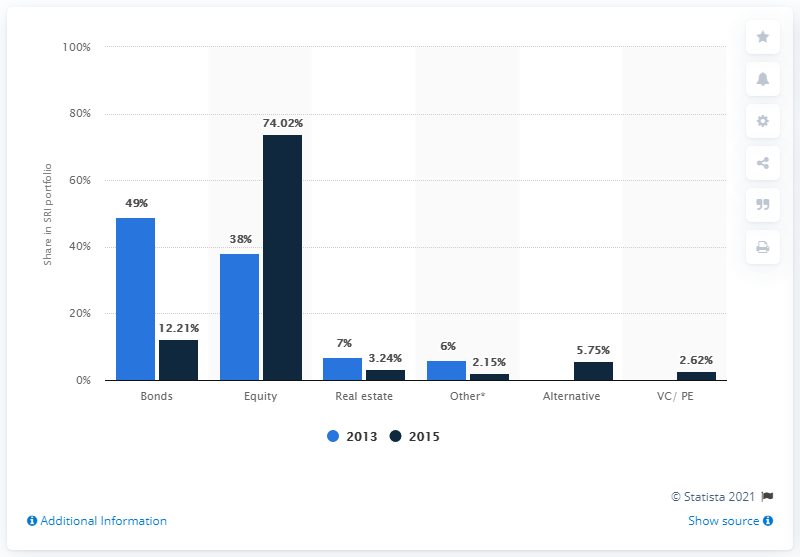Highlight a few significant elements in this photo. The average of bonds and equity combined is 43.31. Finlands SRI-portefølje blev i 2013 delt efter typer af aktier. The year with the largest value is 2015. 